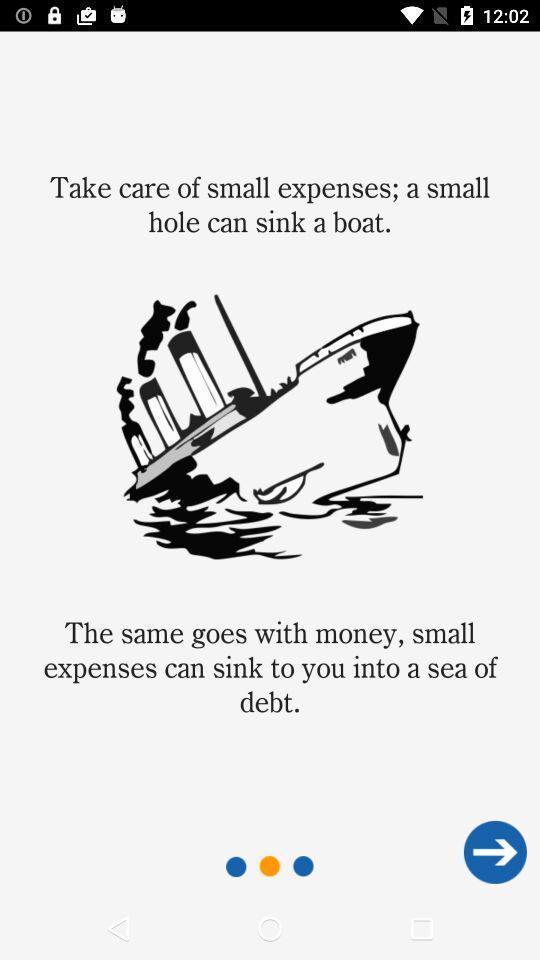Describe the content in this image. Welcome page of expenditures tracking application. 